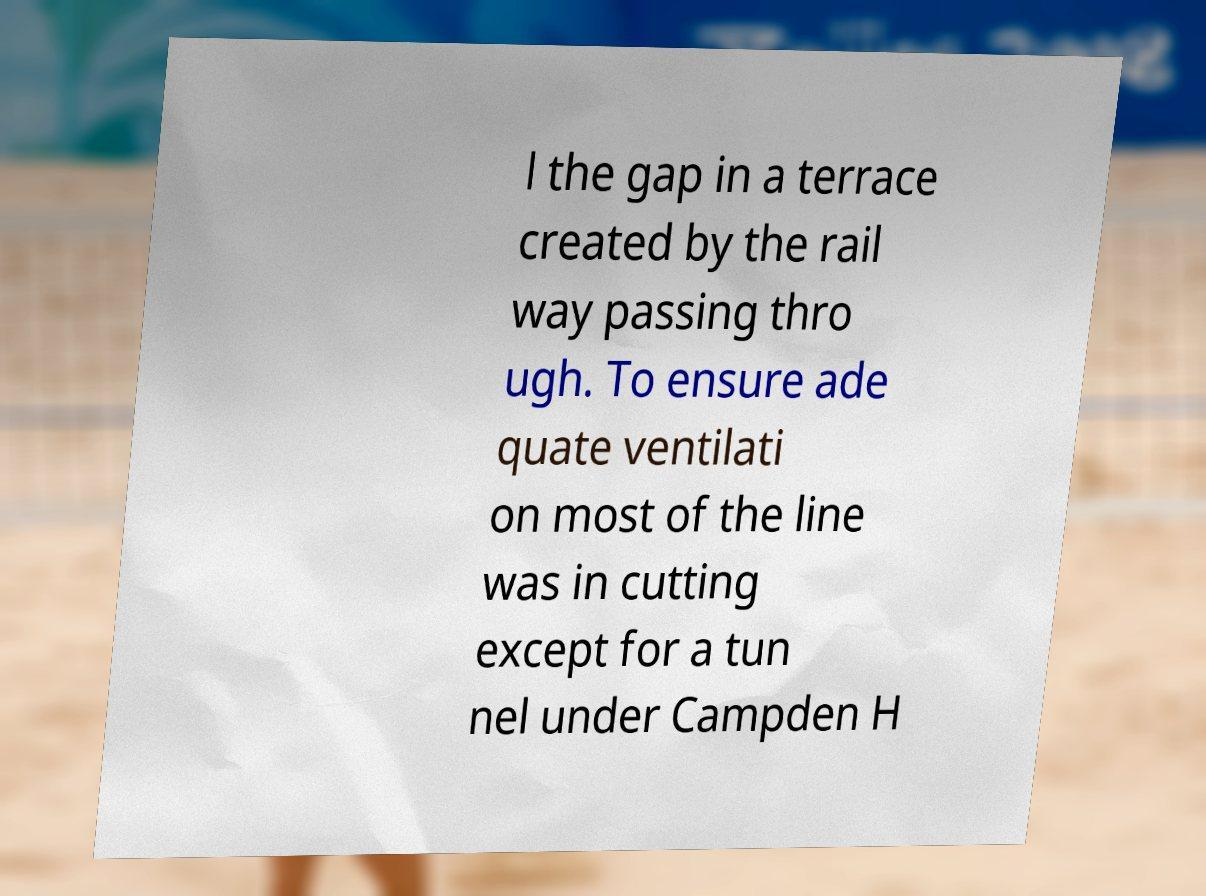What messages or text are displayed in this image? I need them in a readable, typed format. l the gap in a terrace created by the rail way passing thro ugh. To ensure ade quate ventilati on most of the line was in cutting except for a tun nel under Campden H 